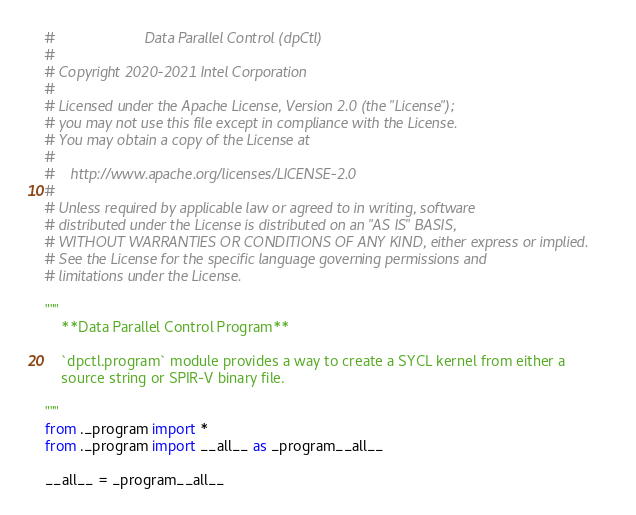Convert code to text. <code><loc_0><loc_0><loc_500><loc_500><_Python_>#                      Data Parallel Control (dpCtl)
#
# Copyright 2020-2021 Intel Corporation
#
# Licensed under the Apache License, Version 2.0 (the "License");
# you may not use this file except in compliance with the License.
# You may obtain a copy of the License at
#
#    http://www.apache.org/licenses/LICENSE-2.0
#
# Unless required by applicable law or agreed to in writing, software
# distributed under the License is distributed on an "AS IS" BASIS,
# WITHOUT WARRANTIES OR CONDITIONS OF ANY KIND, either express or implied.
# See the License for the specific language governing permissions and
# limitations under the License.

"""
    **Data Parallel Control Program**

    `dpctl.program` module provides a way to create a SYCL kernel from either a
    source string or SPIR-V binary file.

"""
from ._program import *
from ._program import __all__ as _program__all__

__all__ = _program__all__
</code> 